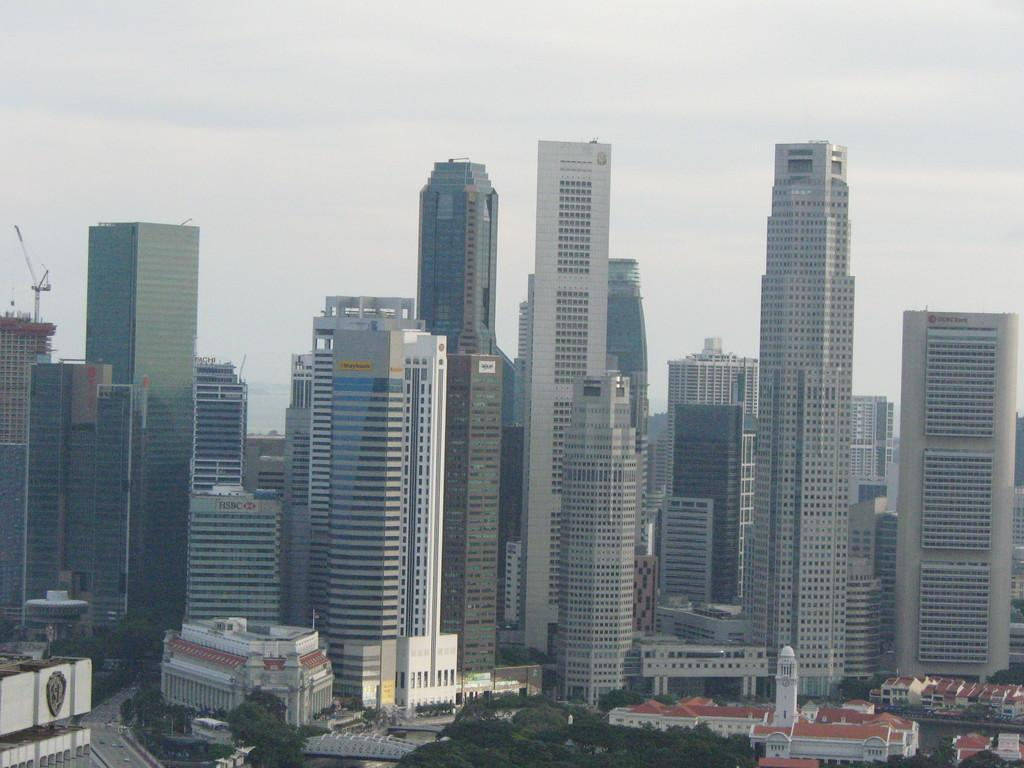What type of structures can be seen in the image? There are buildings in the image. What else is present on the ground in the image? There are trees on the ground in the image. What can be seen in the background of the image? The sky is visible in the background of the image. What is the condition of the sky in the image? There are clouds in the sky in the image. What type of polish is being applied to the buildings in the image? There is no indication in the image that any polish is being applied to the buildings. 